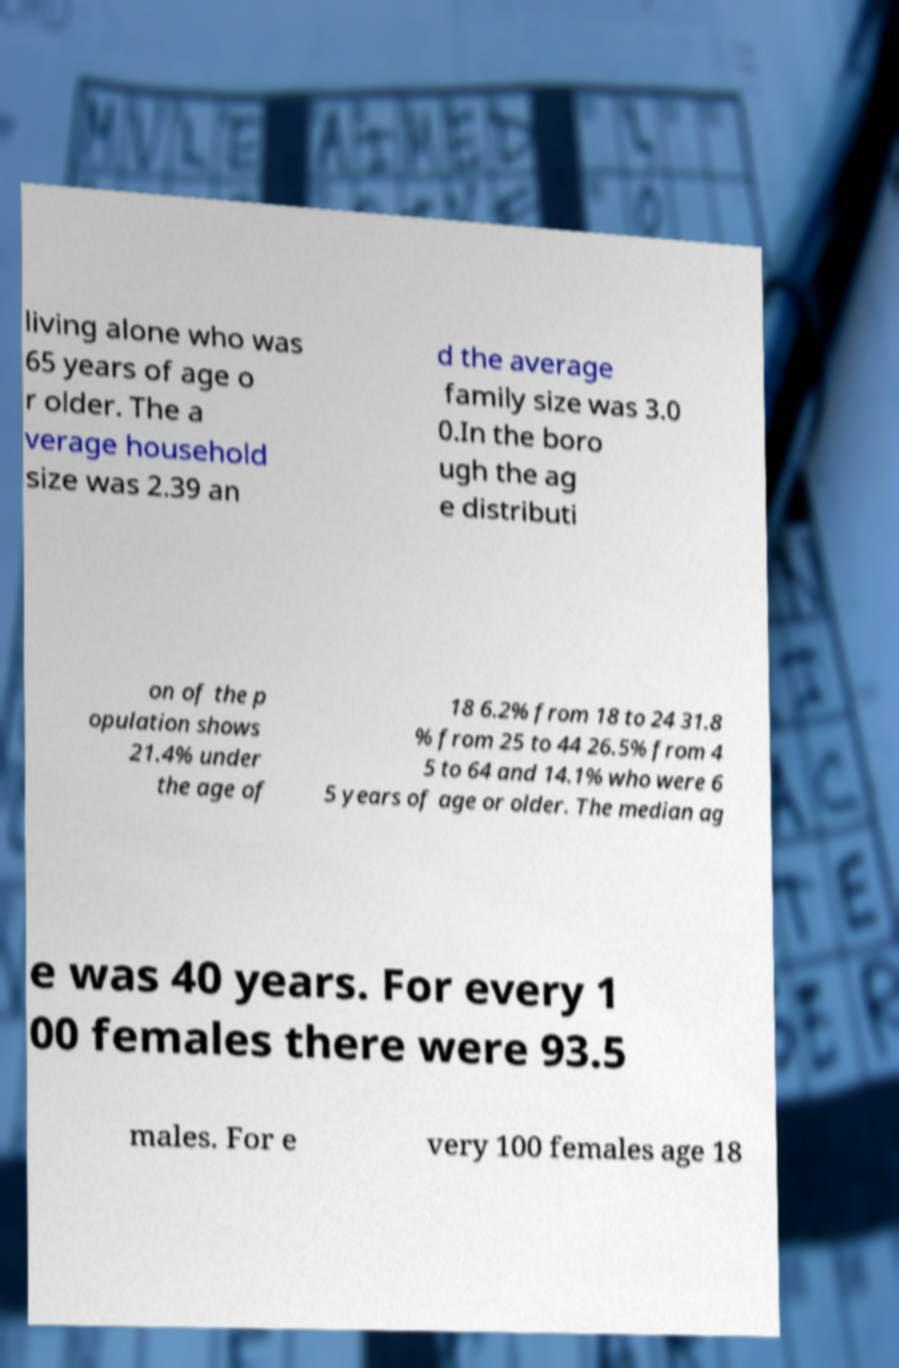What messages or text are displayed in this image? I need them in a readable, typed format. living alone who was 65 years of age o r older. The a verage household size was 2.39 an d the average family size was 3.0 0.In the boro ugh the ag e distributi on of the p opulation shows 21.4% under the age of 18 6.2% from 18 to 24 31.8 % from 25 to 44 26.5% from 4 5 to 64 and 14.1% who were 6 5 years of age or older. The median ag e was 40 years. For every 1 00 females there were 93.5 males. For e very 100 females age 18 